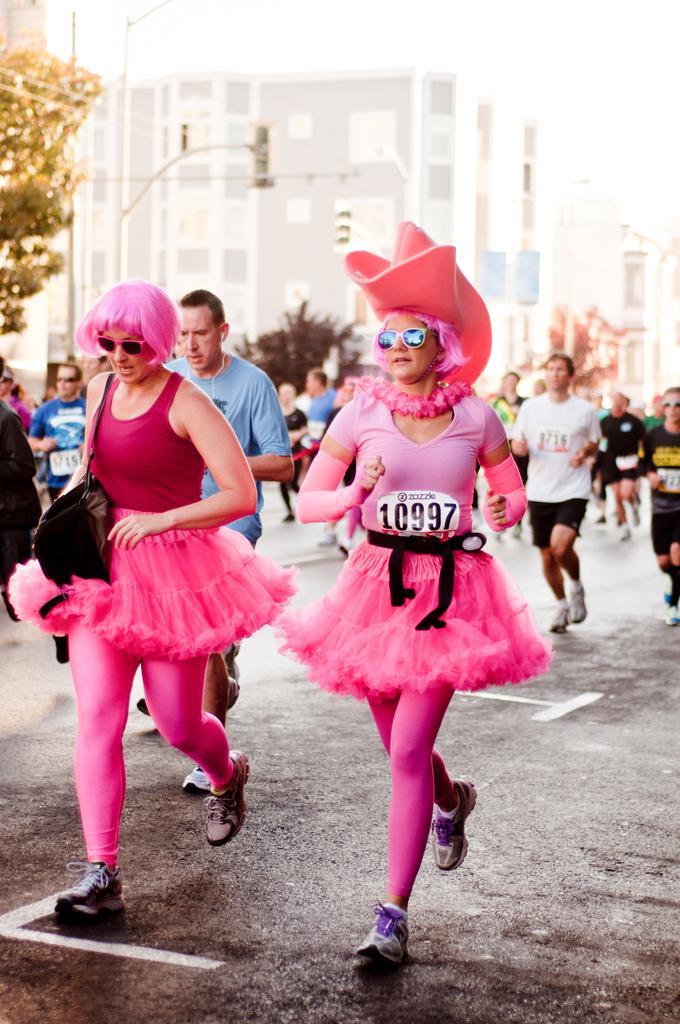How would you summarize this image in a sentence or two? This picture describes about group of people, they are running on the road, in the middle of the image we can see two women, they wore pink color dresses, in the background we can see few poles, buildings and trees. 